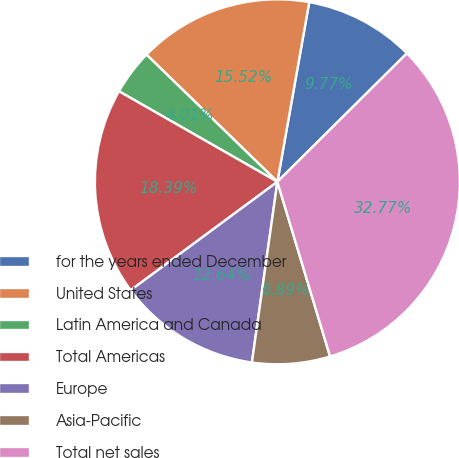Convert chart. <chart><loc_0><loc_0><loc_500><loc_500><pie_chart><fcel>for the years ended December<fcel>United States<fcel>Latin America and Canada<fcel>Total Americas<fcel>Europe<fcel>Asia-Pacific<fcel>Total net sales<nl><fcel>9.77%<fcel>15.52%<fcel>4.01%<fcel>18.39%<fcel>12.64%<fcel>6.89%<fcel>32.77%<nl></chart> 